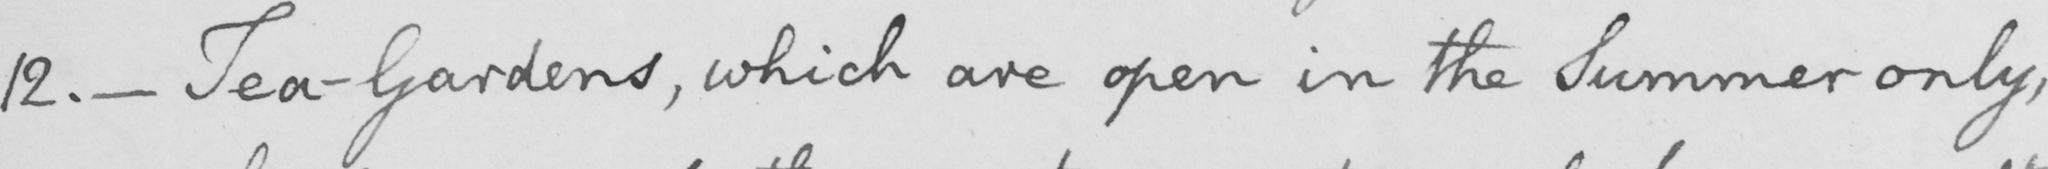What is written in this line of handwriting? 12 .  _  Tea-Gardens , which are open in the Summer only , 